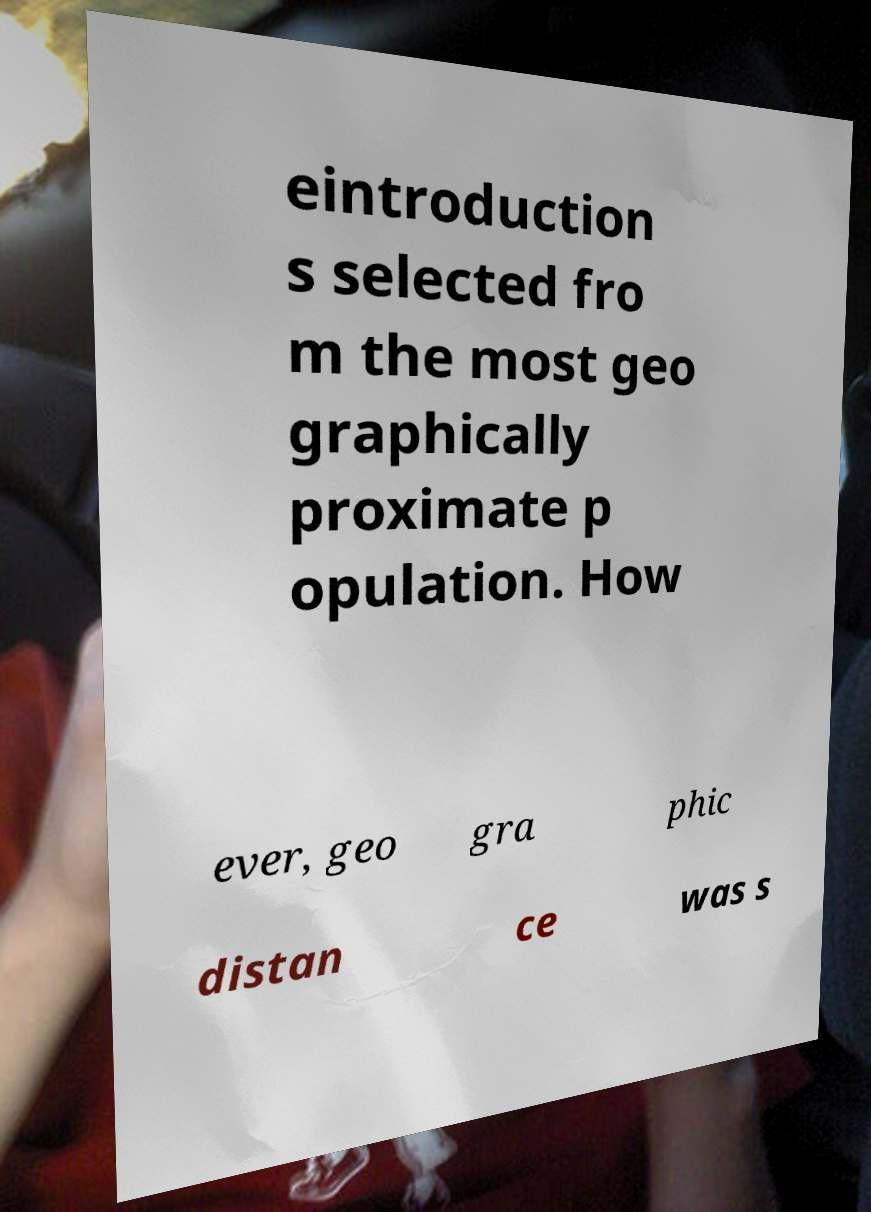I need the written content from this picture converted into text. Can you do that? eintroduction s selected fro m the most geo graphically proximate p opulation. How ever, geo gra phic distan ce was s 